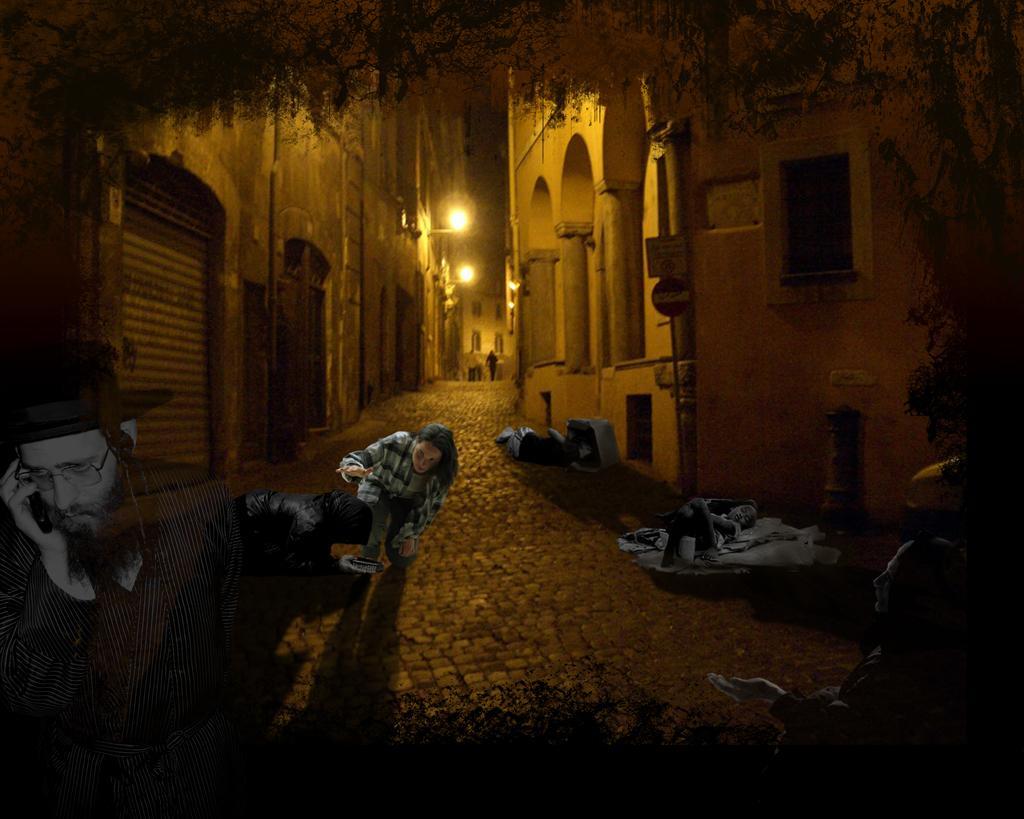Please provide a concise description of this image. In this edited image there is a path. On the either sides of the path there are buildings. There are lights to the walls of the building. At the top there are leaves of a tree. There are edited pictures of people sleeping on the path. In the center there is an edited picture of a woman in squat position. To the left there is a man standing. 